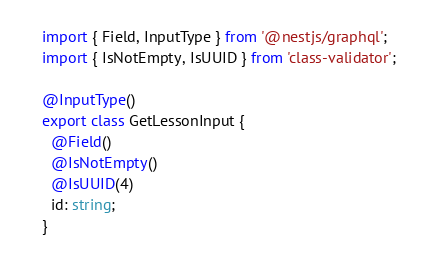<code> <loc_0><loc_0><loc_500><loc_500><_TypeScript_>import { Field, InputType } from '@nestjs/graphql';
import { IsNotEmpty, IsUUID } from 'class-validator';

@InputType()
export class GetLessonInput {
  @Field()
  @IsNotEmpty()
  @IsUUID(4)
  id: string;
}
</code> 